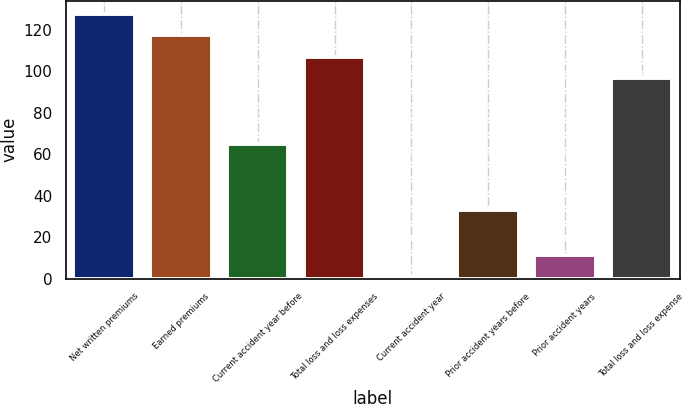Convert chart to OTSL. <chart><loc_0><loc_0><loc_500><loc_500><bar_chart><fcel>Net written premiums<fcel>Earned premiums<fcel>Current accident year before<fcel>Total loss and loss expenses<fcel>Current accident year<fcel>Prior accident years before<fcel>Prior accident years<fcel>Total loss and loss expense<nl><fcel>127.57<fcel>117.28<fcel>65<fcel>106.99<fcel>1.11<fcel>33<fcel>11.4<fcel>96.7<nl></chart> 